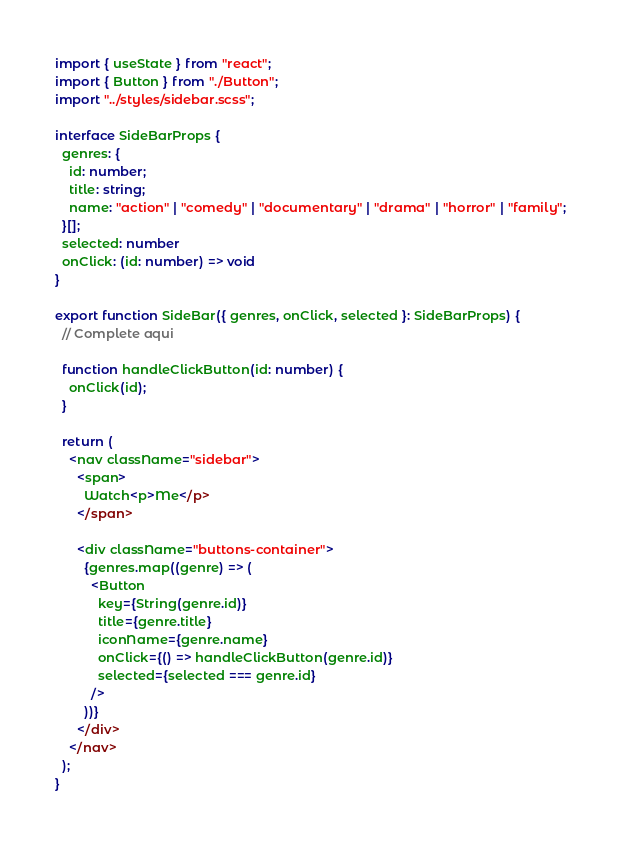Convert code to text. <code><loc_0><loc_0><loc_500><loc_500><_TypeScript_>import { useState } from "react";
import { Button } from "./Button";
import "../styles/sidebar.scss";

interface SideBarProps {
  genres: {
    id: number;
    title: string;
    name: "action" | "comedy" | "documentary" | "drama" | "horror" | "family";
  }[];
  selected: number
  onClick: (id: number) => void
}

export function SideBar({ genres, onClick, selected }: SideBarProps) {
  // Complete aqui

  function handleClickButton(id: number) {
    onClick(id);
  }

  return (
    <nav className="sidebar">
      <span>
        Watch<p>Me</p>
      </span>

      <div className="buttons-container">
        {genres.map((genre) => (
          <Button
            key={String(genre.id)}
            title={genre.title}
            iconName={genre.name}
            onClick={() => handleClickButton(genre.id)}
            selected={selected === genre.id}
          />
        ))}
      </div>
    </nav>
  );
}
</code> 